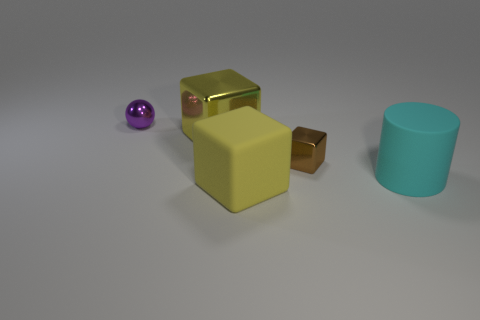Subtract all purple balls. How many yellow blocks are left? 2 Subtract all big blocks. How many blocks are left? 1 Add 1 brown metal cubes. How many objects exist? 6 Subtract all gray blocks. Subtract all green cylinders. How many blocks are left? 3 Subtract all small red balls. Subtract all big shiny objects. How many objects are left? 4 Add 4 large cubes. How many large cubes are left? 6 Add 5 brown shiny cubes. How many brown shiny cubes exist? 6 Subtract 0 purple blocks. How many objects are left? 5 Subtract all cylinders. How many objects are left? 4 